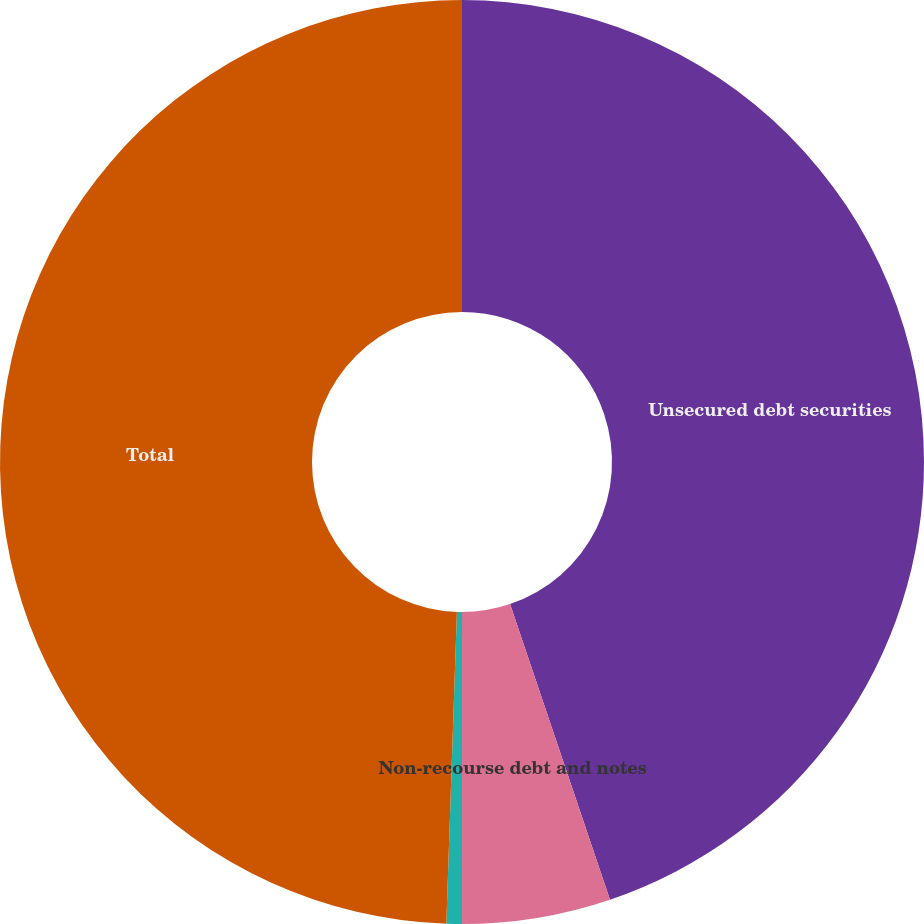<chart> <loc_0><loc_0><loc_500><loc_500><pie_chart><fcel>Unsecured debt securities<fcel>Non-recourse debt and notes<fcel>Capital lease obligations<fcel>Total<nl><fcel>44.81%<fcel>5.19%<fcel>0.54%<fcel>49.46%<nl></chart> 